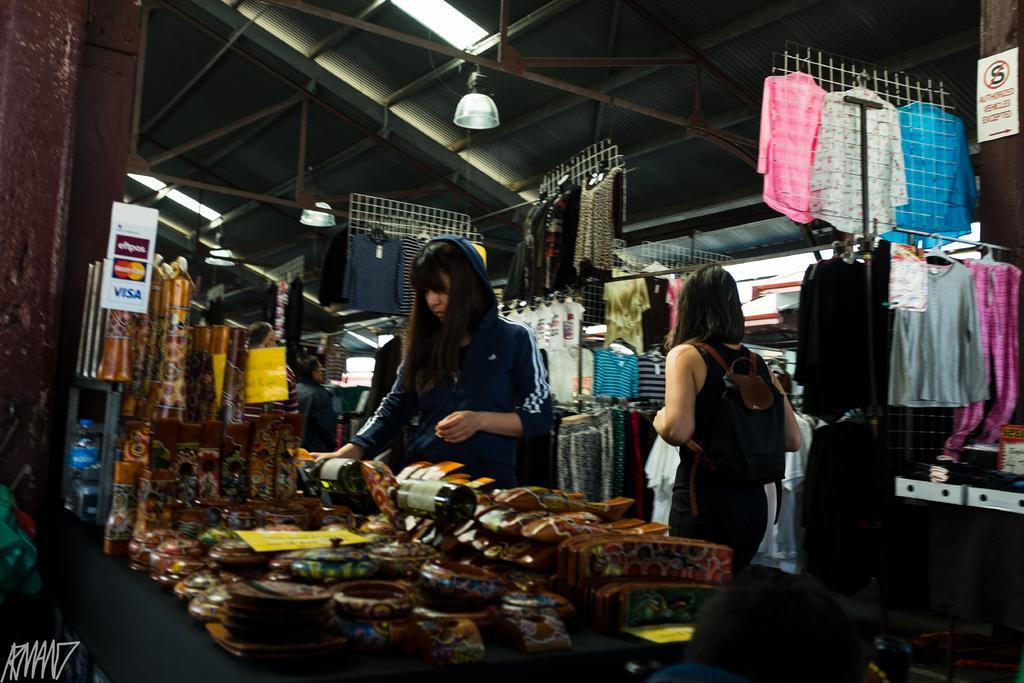Describe this image in one or two sentences. In this picture I can see couple of them standing and woman wore a backpack and I can see few items on the table and I can see few clothes to the hangers and I can see lights on the ceiling and a board with some text. 